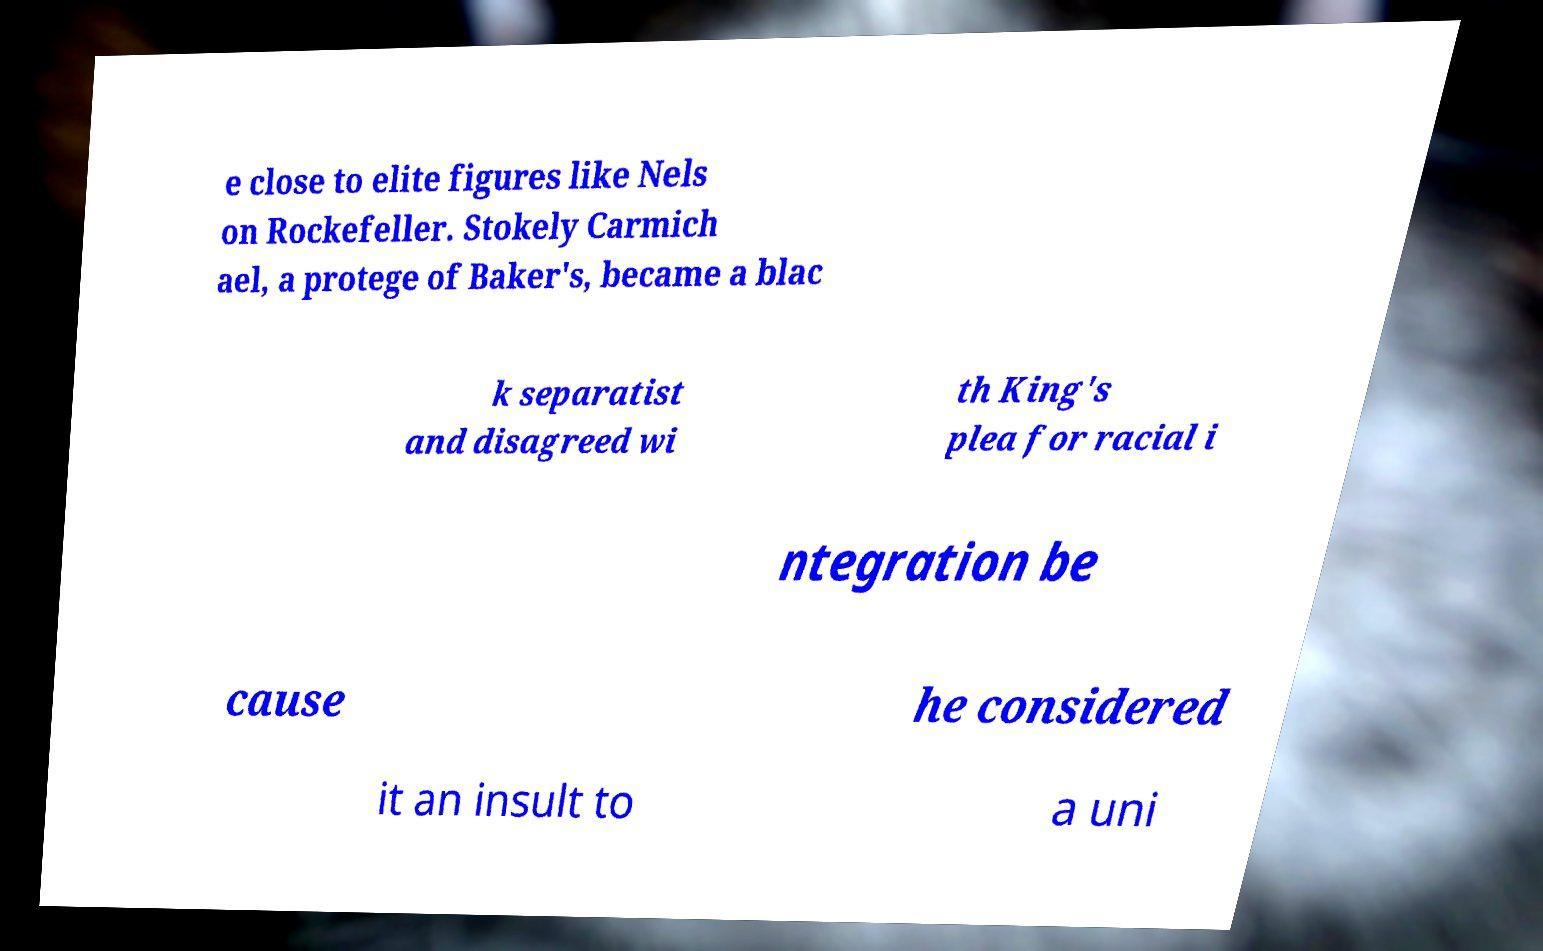I need the written content from this picture converted into text. Can you do that? e close to elite figures like Nels on Rockefeller. Stokely Carmich ael, a protege of Baker's, became a blac k separatist and disagreed wi th King's plea for racial i ntegration be cause he considered it an insult to a uni 